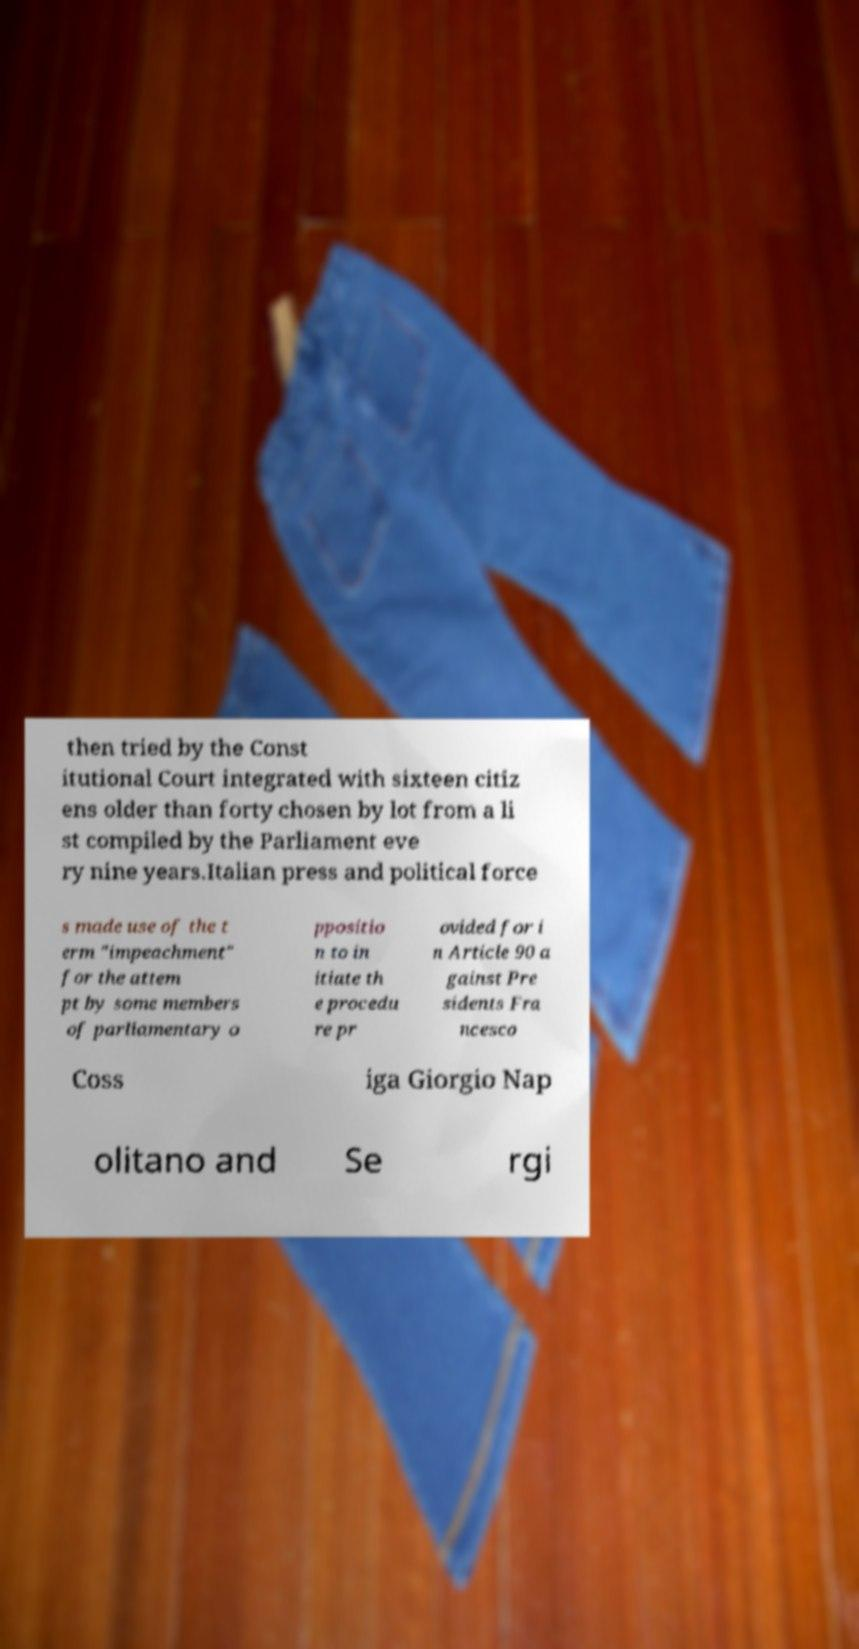There's text embedded in this image that I need extracted. Can you transcribe it verbatim? then tried by the Const itutional Court integrated with sixteen citiz ens older than forty chosen by lot from a li st compiled by the Parliament eve ry nine years.Italian press and political force s made use of the t erm "impeachment" for the attem pt by some members of parliamentary o ppositio n to in itiate th e procedu re pr ovided for i n Article 90 a gainst Pre sidents Fra ncesco Coss iga Giorgio Nap olitano and Se rgi 